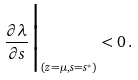Convert formula to latex. <formula><loc_0><loc_0><loc_500><loc_500>\frac { \partial \lambda } { \partial s } \Big | _ { ( z = \mu , s = s ^ { * } ) } < 0 \, .</formula> 